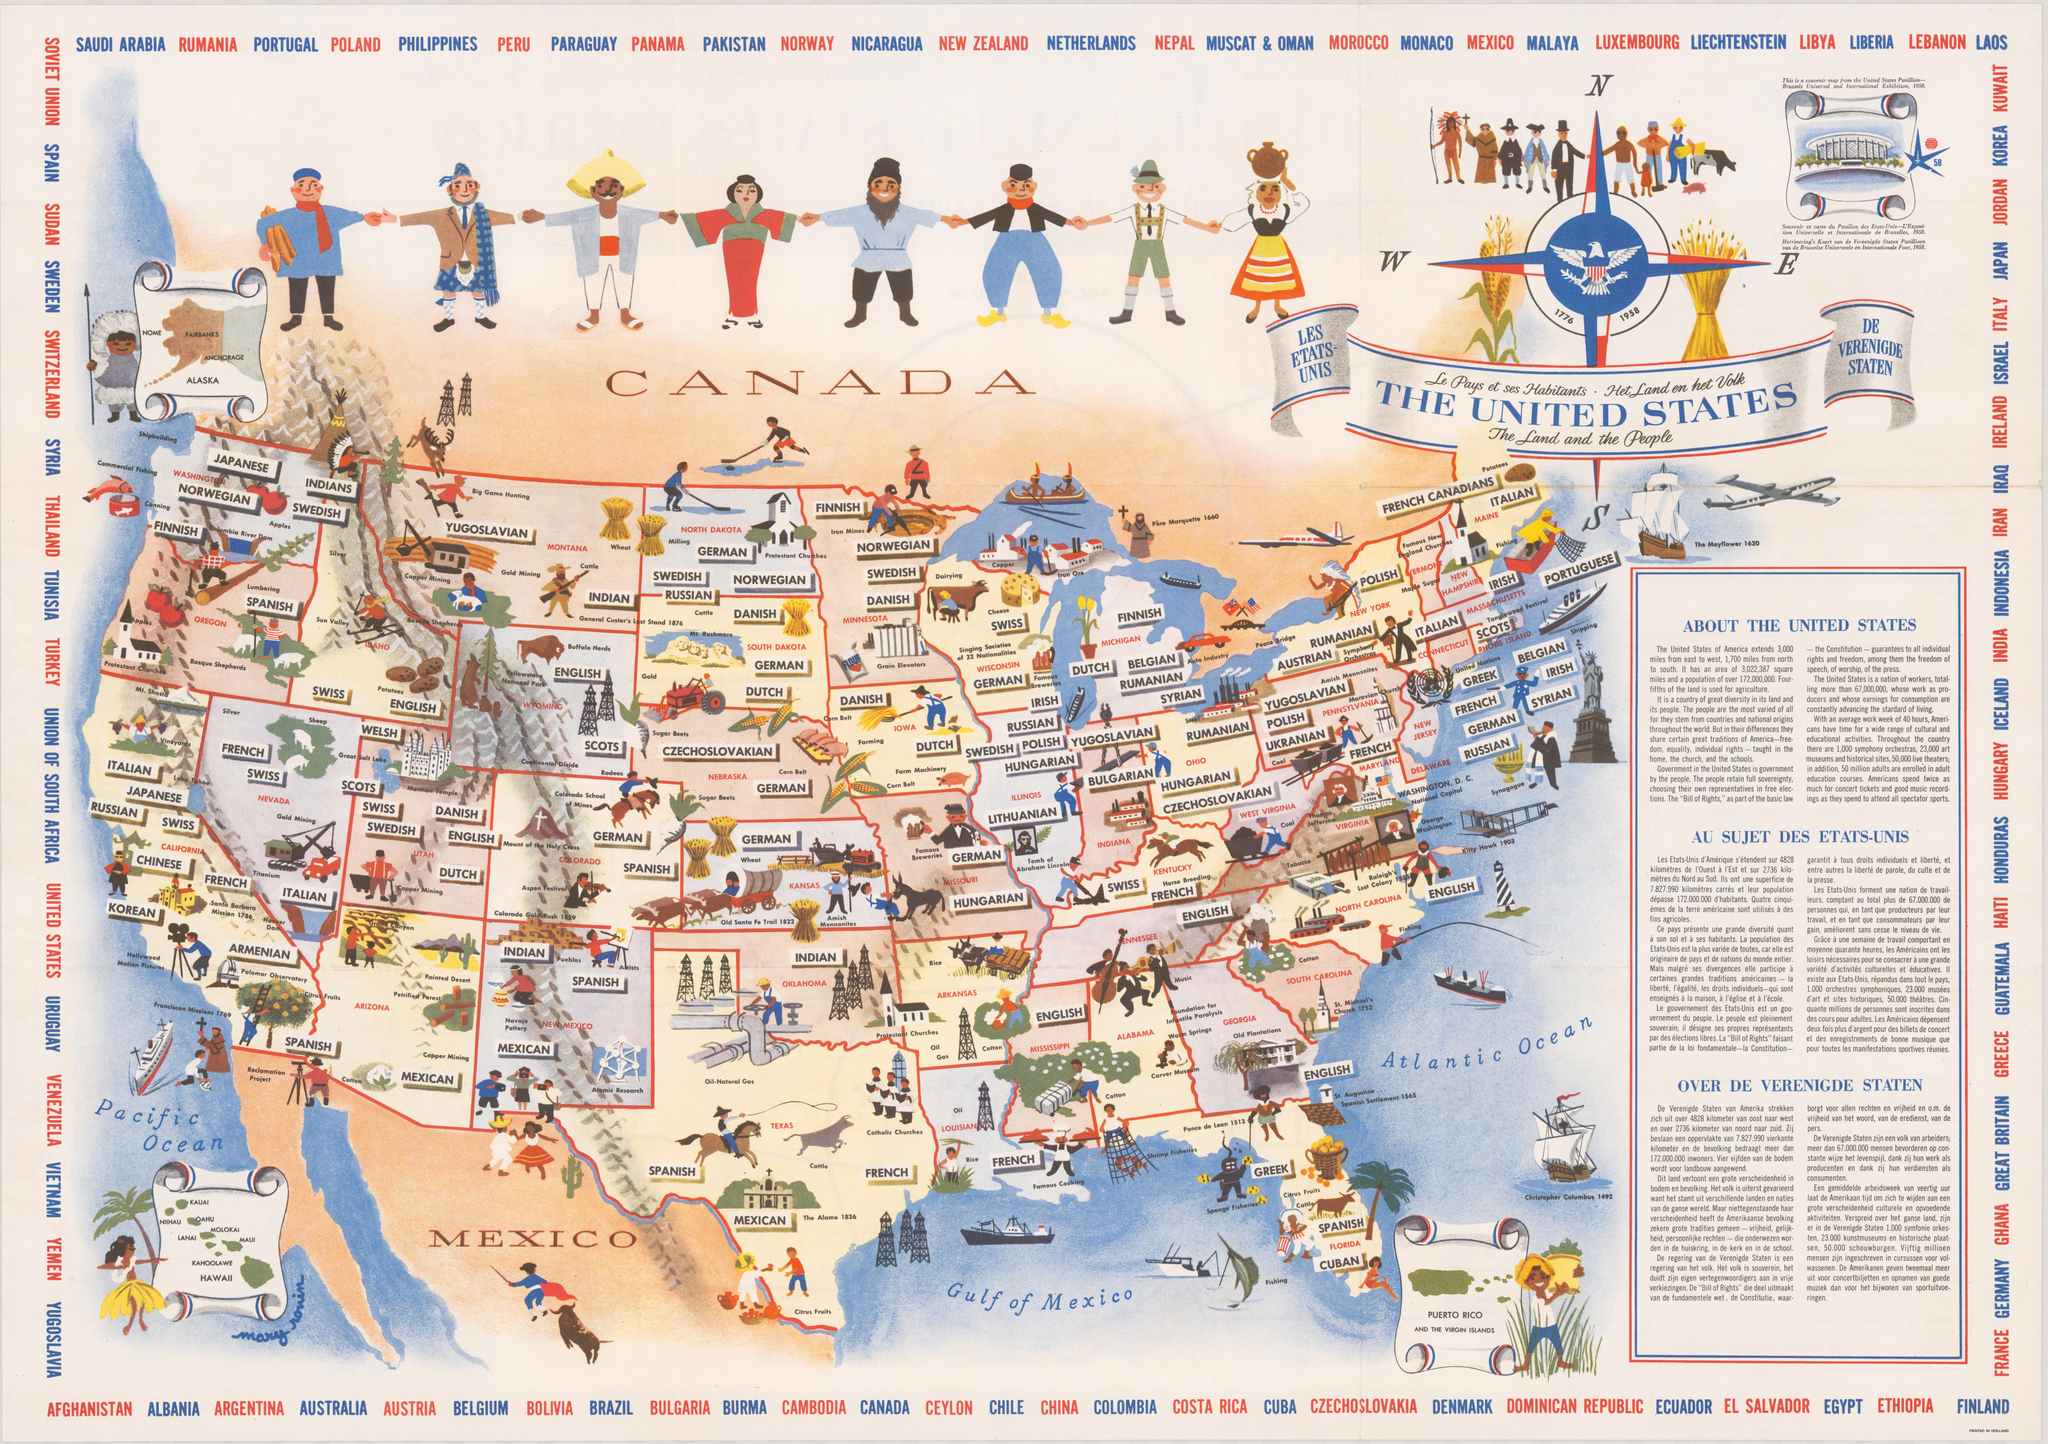Highlight a few significant elements in this photo. The great traditions of America, including freedom, equality, and individual rights, are shared by the people. The eastern extent of the United States is approximately 3,000 miles. The north to south extent of the United States is approximately 1,700 miles. Abraham Lincoln's tomb is located in the state of Illinois. St. Michael's church was located in South Carolina in 1752. 